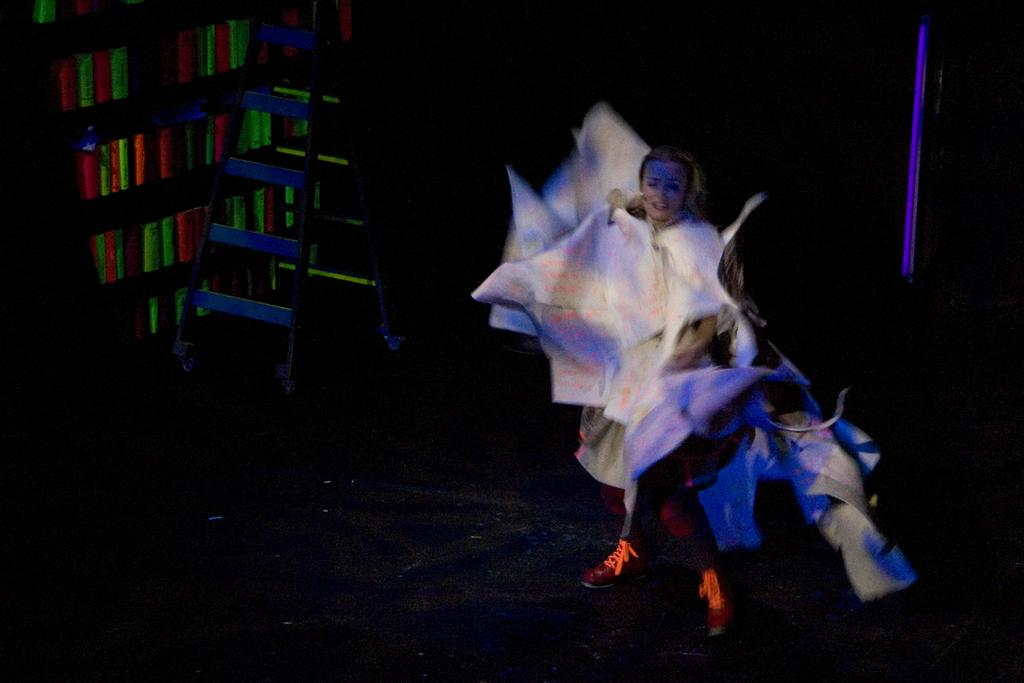Who is present in the image? There is a woman in the image. What can be seen on the left side of the image? There is a stand on the left side of the image. What type of objects are visible in the bookshelf? There are books in a bookshelf. How would you describe the lighting in the image? The background of the image is dark. How many brothers does the woman have in the image? There is no information about the woman's brothers in the image. Can you tell me if the woman sneezed while the image was taken? There is no indication of the woman sneezing in the image. 